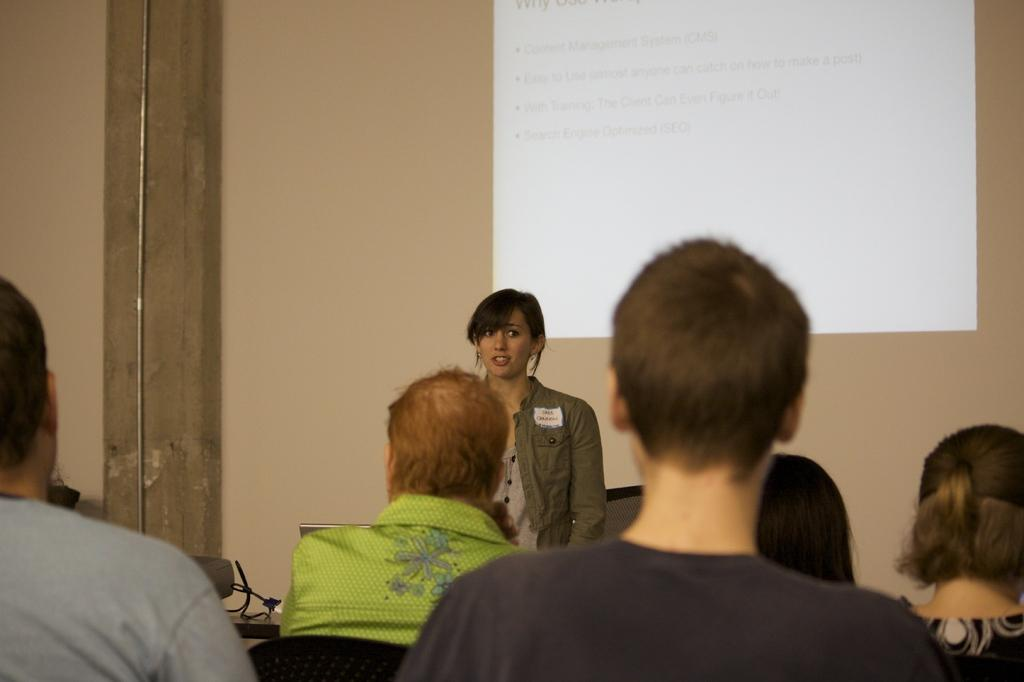How many people are in the image? There is a group of people in the image. What are some of the people in the image doing? Some people are sitting, and there is a person standing and looking to the right. What can be seen in the background of the image? There is a well, a screen, a pipe, and wires in the background. What type of growth is being judged by the person standing in the image? There is no growth or judge present in the image; it features a group of people with various actions and positions. What type of stove is visible in the image? There is no stove present in the image. 